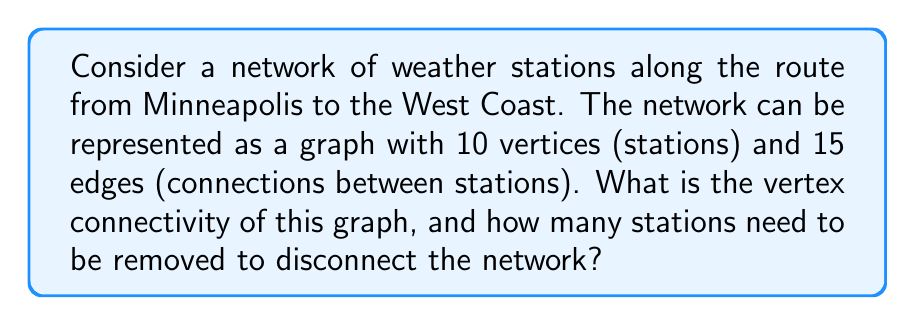Show me your answer to this math problem. To solve this problem, we need to understand the concept of vertex connectivity in graph theory and apply it to our weather station network.

1. Vertex connectivity definition:
   The vertex connectivity of a graph, denoted as $\kappa(G)$, is the minimum number of vertices that need to be removed to disconnect the graph.

2. For our weather station network:
   - We have 10 vertices (stations)
   - We have 15 edges (connections)

3. To find the vertex connectivity, we need to consider the following theorem:
   For any graph $G$ that is not a complete graph, $\kappa(G) \leq \delta(G)$, where $\delta(G)$ is the minimum degree of the graph.

4. Calculate the maximum possible edges in a complete graph with 10 vertices:
   $$\text{Max edges} = \frac{n(n-1)}{2} = \frac{10(9)}{2} = 45$$

5. Since our graph has only 15 edges, it is not a complete graph. Therefore, we can apply the theorem.

6. Calculate the average degree of the graph:
   $$\text{Average degree} = \frac{2 \times \text{number of edges}}{\text{number of vertices}} = \frac{2 \times 15}{10} = 3$$

7. The minimum degree $\delta(G)$ must be less than or equal to the average degree. Let's assume $\delta(G) = 3$ (it could be less, but this gives us an upper bound).

8. By the theorem, $\kappa(G) \leq \delta(G) = 3$

9. This means that the vertex connectivity of our weather station network is at most 3.

Therefore, at most 3 stations need to be removed to disconnect the network.
Answer: The vertex connectivity of the weather station network is at most 3, and at most 3 stations need to be removed to disconnect the network. 